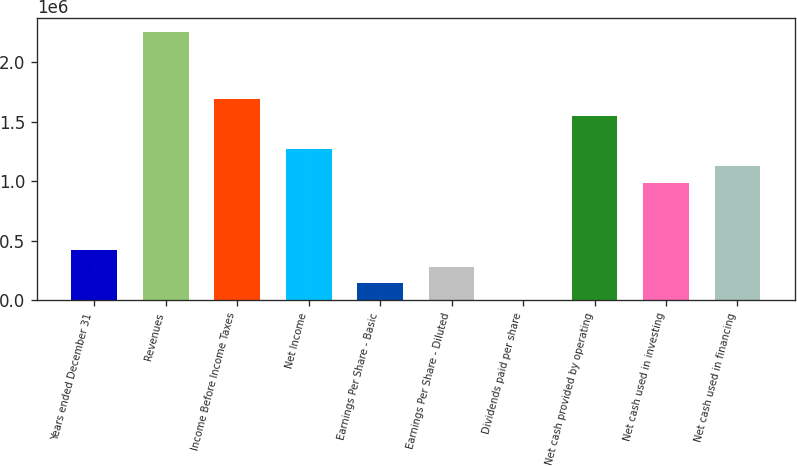Convert chart. <chart><loc_0><loc_0><loc_500><loc_500><bar_chart><fcel>Years ended December 31<fcel>Revenues<fcel>Income Before Income Taxes<fcel>Net Income<fcel>Earnings Per Share - Basic<fcel>Earnings Per Share - Diluted<fcel>Dividends paid per share<fcel>Net cash provided by operating<fcel>Net cash used in investing<fcel>Net cash used in financing<nl><fcel>423470<fcel>2.25851e+06<fcel>1.69388e+06<fcel>1.27041e+06<fcel>141157<fcel>282314<fcel>0.52<fcel>1.55272e+06<fcel>988096<fcel>1.12925e+06<nl></chart> 